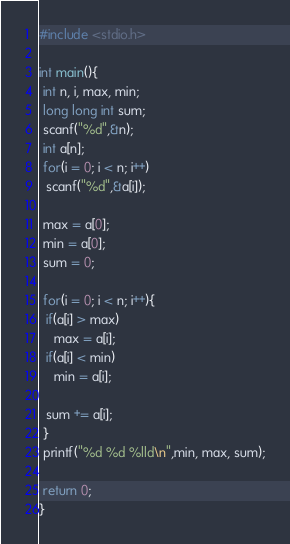Convert code to text. <code><loc_0><loc_0><loc_500><loc_500><_C_>#include <stdio.h>

int main(){
 int n, i, max, min;
 long long int sum;
 scanf("%d",&n);
 int a[n];
 for(i = 0; i < n; i++)
  scanf("%d",&a[i]);
 
 max = a[0];
 min = a[0];
 sum = 0;

 for(i = 0; i < n; i++){
  if(a[i] > max)
    max = a[i];
  if(a[i] < min)
    min = a[i];

  sum += a[i];
 } 
 printf("%d %d %lld\n",min, max, sum);
 
 return 0;
} </code> 